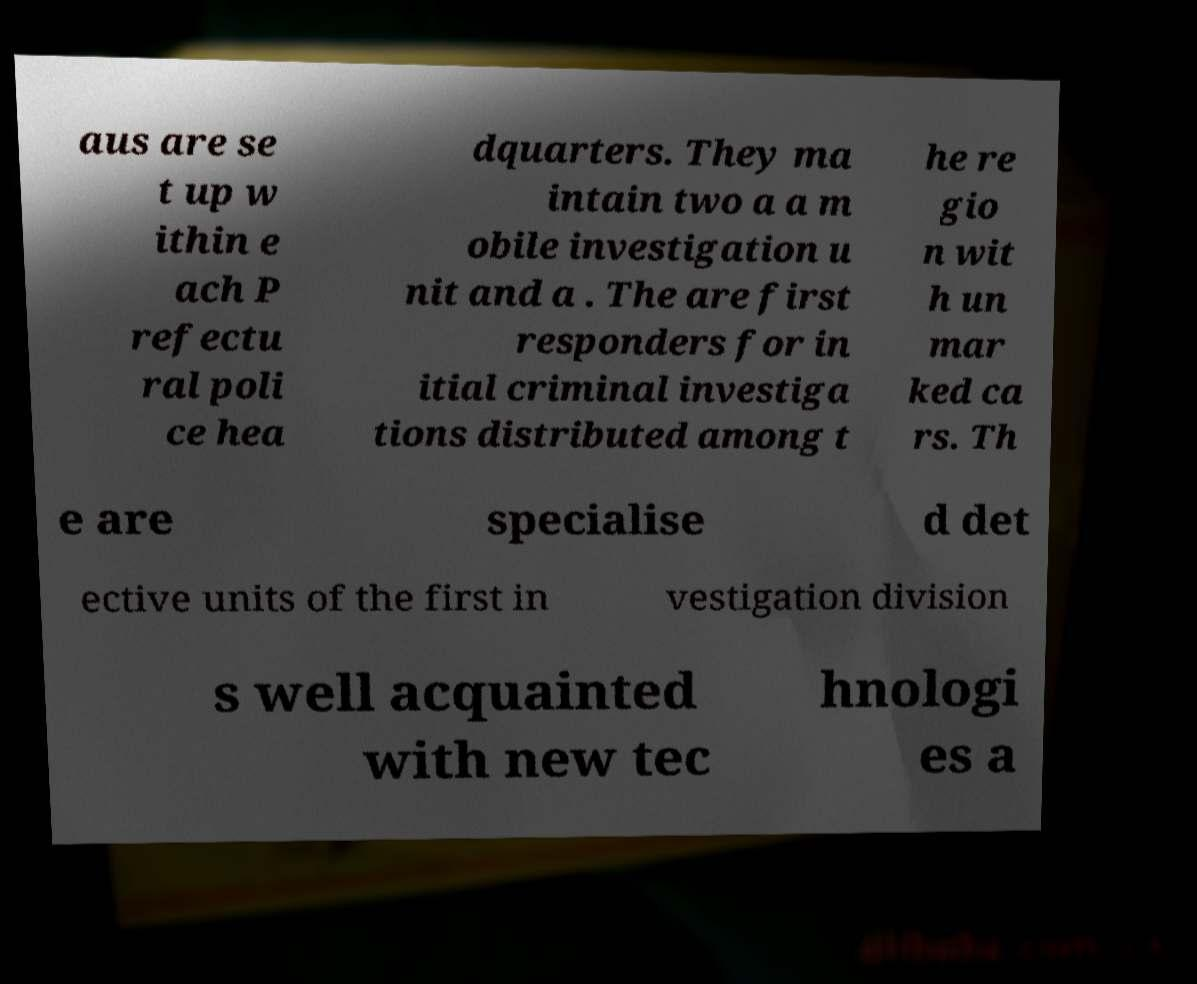Please read and relay the text visible in this image. What does it say? aus are se t up w ithin e ach P refectu ral poli ce hea dquarters. They ma intain two a a m obile investigation u nit and a . The are first responders for in itial criminal investiga tions distributed among t he re gio n wit h un mar ked ca rs. Th e are specialise d det ective units of the first in vestigation division s well acquainted with new tec hnologi es a 